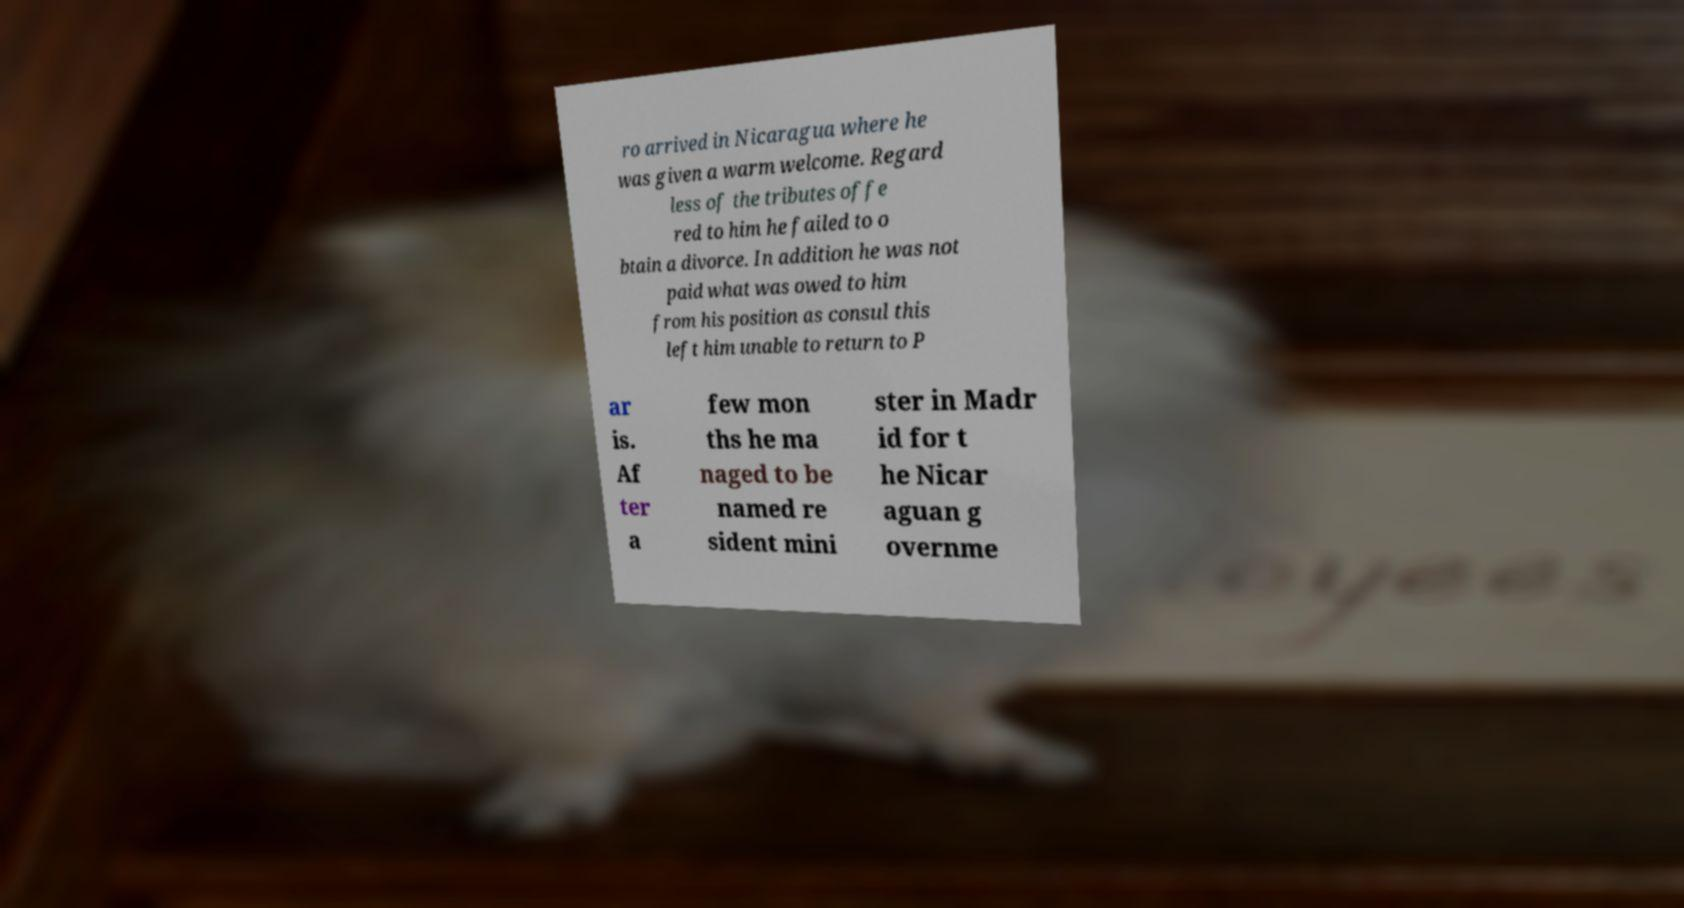For documentation purposes, I need the text within this image transcribed. Could you provide that? ro arrived in Nicaragua where he was given a warm welcome. Regard less of the tributes offe red to him he failed to o btain a divorce. In addition he was not paid what was owed to him from his position as consul this left him unable to return to P ar is. Af ter a few mon ths he ma naged to be named re sident mini ster in Madr id for t he Nicar aguan g overnme 